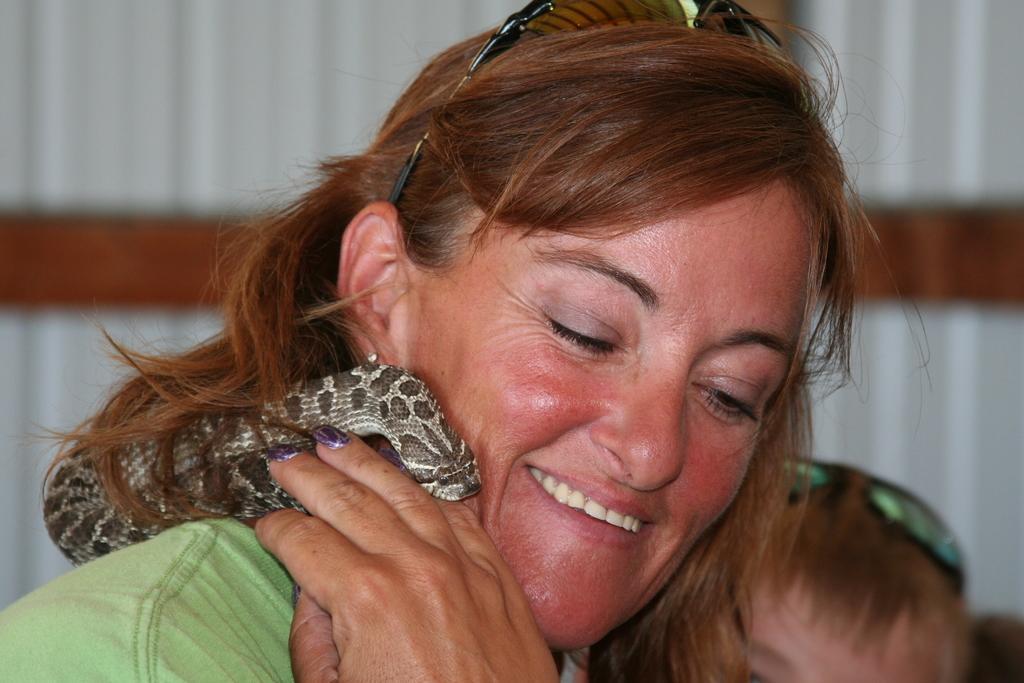Can you describe this image briefly? In this picture there is a woman who is holding a scarf. There is also another person. 